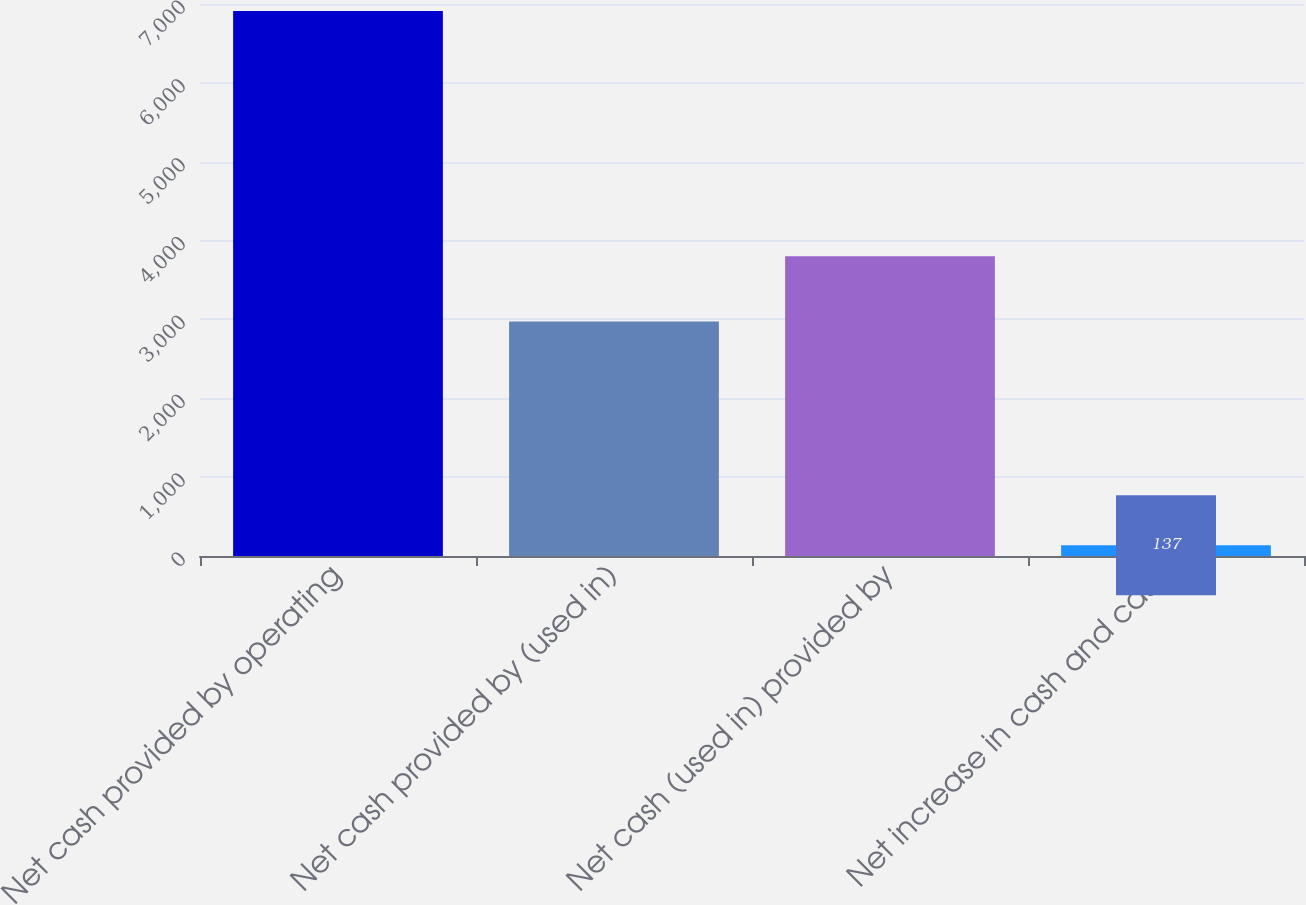Convert chart. <chart><loc_0><loc_0><loc_500><loc_500><bar_chart><fcel>Net cash provided by operating<fcel>Net cash provided by (used in)<fcel>Net cash (used in) provided by<fcel>Net increase in cash and cash<nl><fcel>6911<fcel>2974<fcel>3800<fcel>137<nl></chart> 